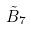Convert formula to latex. <formula><loc_0><loc_0><loc_500><loc_500>\tilde { B } _ { 7 }</formula> 